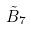Convert formula to latex. <formula><loc_0><loc_0><loc_500><loc_500>\tilde { B } _ { 7 }</formula> 